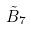Convert formula to latex. <formula><loc_0><loc_0><loc_500><loc_500>\tilde { B } _ { 7 }</formula> 